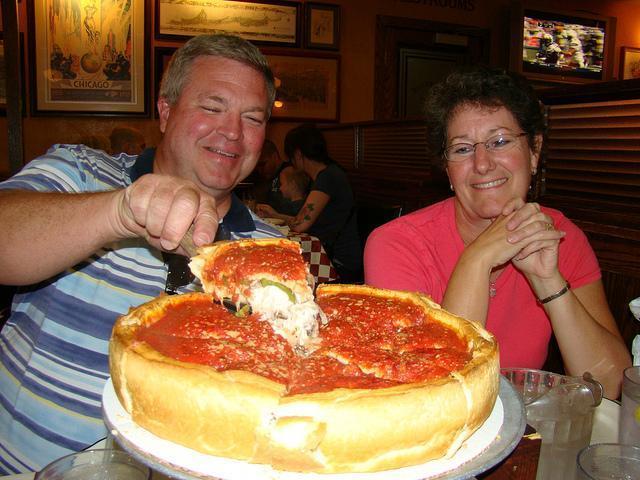How many glasses are there?
Give a very brief answer. 2. How many pizzas are there?
Give a very brief answer. 2. How many people are there?
Give a very brief answer. 3. 